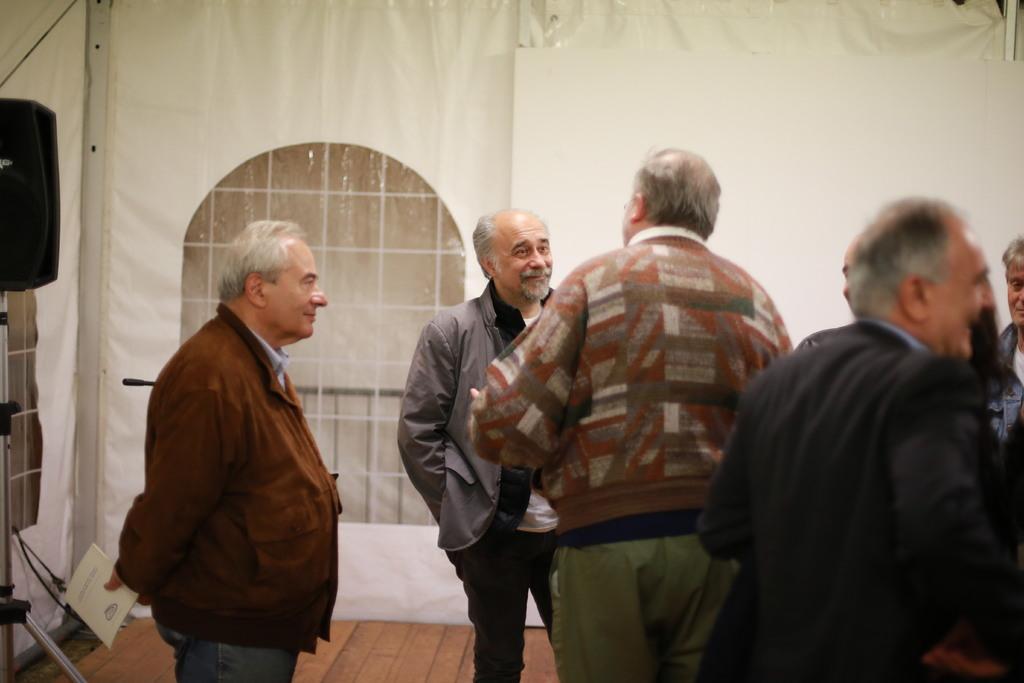Please provide a concise description of this image. In this image, we can see persons wearing clothes. There is a window in the middle of the image. There is a person at the bottom of the image holding a book with his hand. 